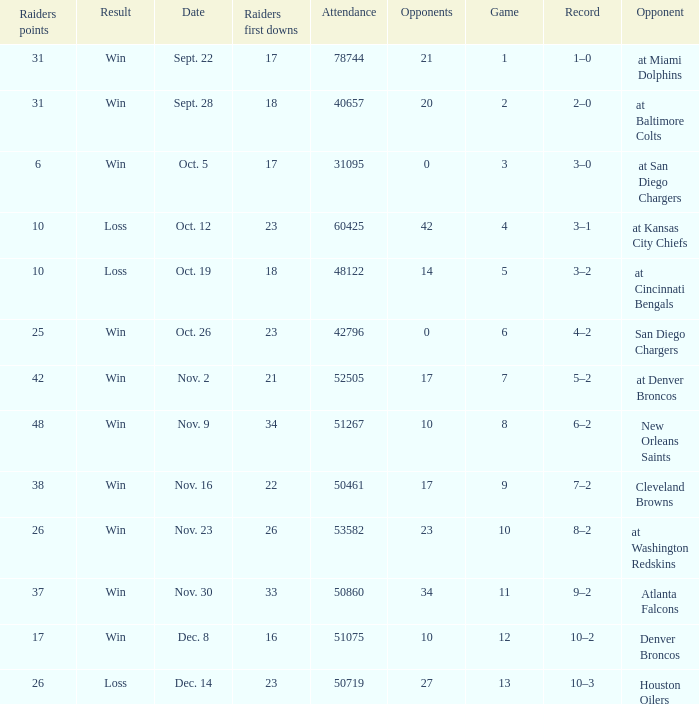I'm looking to parse the entire table for insights. Could you assist me with that? {'header': ['Raiders points', 'Result', 'Date', 'Raiders first downs', 'Attendance', 'Opponents', 'Game', 'Record', 'Opponent'], 'rows': [['31', 'Win', 'Sept. 22', '17', '78744', '21', '1', '1–0', 'at Miami Dolphins'], ['31', 'Win', 'Sept. 28', '18', '40657', '20', '2', '2–0', 'at Baltimore Colts'], ['6', 'Win', 'Oct. 5', '17', '31095', '0', '3', '3–0', 'at San Diego Chargers'], ['10', 'Loss', 'Oct. 12', '23', '60425', '42', '4', '3–1', 'at Kansas City Chiefs'], ['10', 'Loss', 'Oct. 19', '18', '48122', '14', '5', '3–2', 'at Cincinnati Bengals'], ['25', 'Win', 'Oct. 26', '23', '42796', '0', '6', '4–2', 'San Diego Chargers'], ['42', 'Win', 'Nov. 2', '21', '52505', '17', '7', '5–2', 'at Denver Broncos'], ['48', 'Win', 'Nov. 9', '34', '51267', '10', '8', '6–2', 'New Orleans Saints'], ['38', 'Win', 'Nov. 16', '22', '50461', '17', '9', '7–2', 'Cleveland Browns'], ['26', 'Win', 'Nov. 23', '26', '53582', '23', '10', '8–2', 'at Washington Redskins'], ['37', 'Win', 'Nov. 30', '33', '50860', '34', '11', '9–2', 'Atlanta Falcons'], ['17', 'Win', 'Dec. 8', '16', '51075', '10', '12', '10–2', 'Denver Broncos'], ['26', 'Loss', 'Dec. 14', '23', '50719', '27', '13', '10–3', 'Houston Oilers']]} What's the record in the game played against 42? 3–1. 